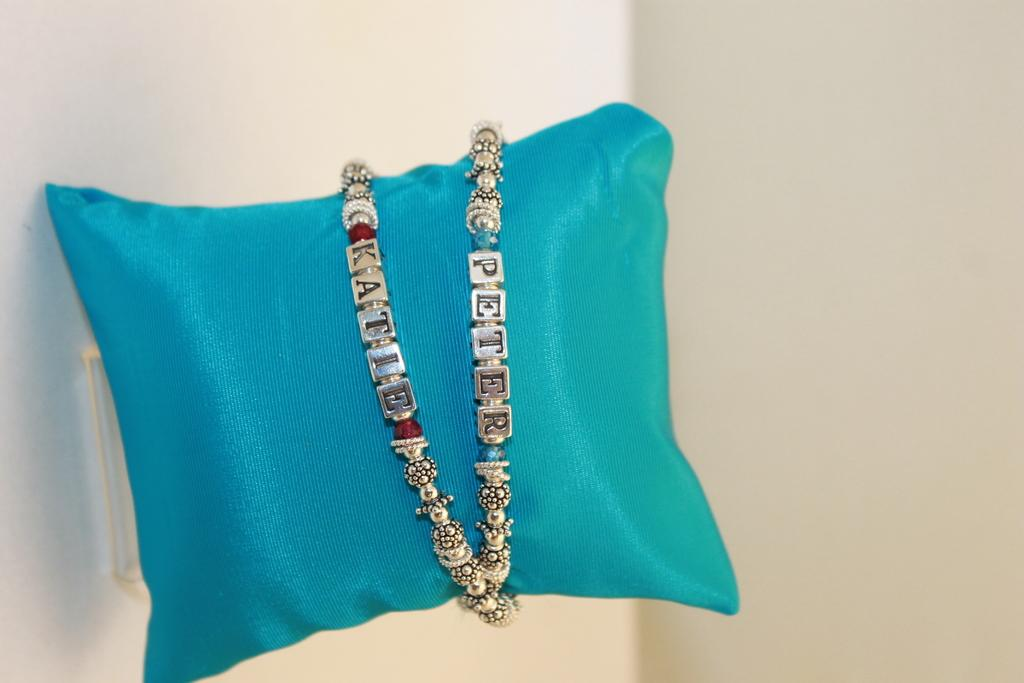What color is the pillow that is visible in the image? There is a blue color pillow in the image. What type of accessory can be seen in the image? There is a bracelet in the image. What is in the background of the image? There is a wall in the background of the image. Is there an advertisement for a new parenting book in the image? There is no advertisement or reference to a parenting book in the image. Can you see the approval rating of the bracelet in the image? There is no indication of an approval rating or any rating system for the bracelet in the image. 